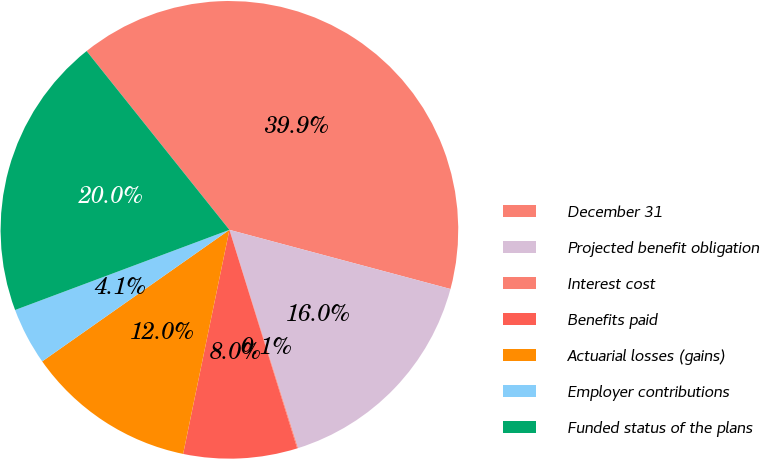Convert chart. <chart><loc_0><loc_0><loc_500><loc_500><pie_chart><fcel>December 31<fcel>Projected benefit obligation<fcel>Interest cost<fcel>Benefits paid<fcel>Actuarial losses (gains)<fcel>Employer contributions<fcel>Funded status of the plans<nl><fcel>39.89%<fcel>15.99%<fcel>0.06%<fcel>8.03%<fcel>12.01%<fcel>4.05%<fcel>19.97%<nl></chart> 